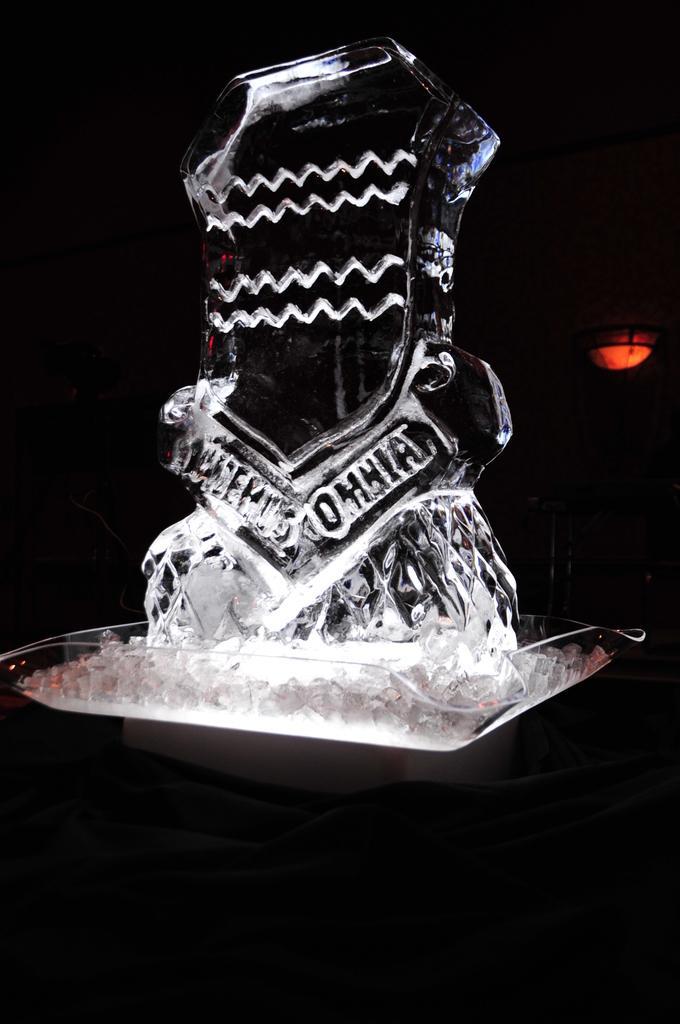Please provide a concise description of this image. Here I can see the glass. The background is in black color. 